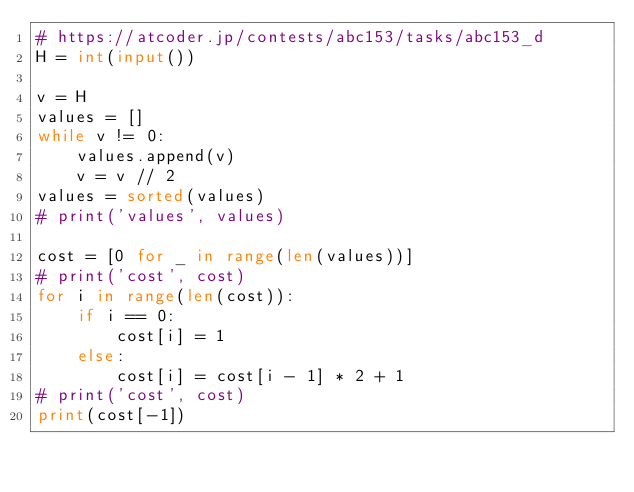<code> <loc_0><loc_0><loc_500><loc_500><_Python_># https://atcoder.jp/contests/abc153/tasks/abc153_d
H = int(input())

v = H
values = []
while v != 0:
    values.append(v)
    v = v // 2
values = sorted(values)
# print('values', values)

cost = [0 for _ in range(len(values))]
# print('cost', cost)
for i in range(len(cost)):
    if i == 0:
        cost[i] = 1
    else:
        cost[i] = cost[i - 1] * 2 + 1
# print('cost', cost)
print(cost[-1])
</code> 